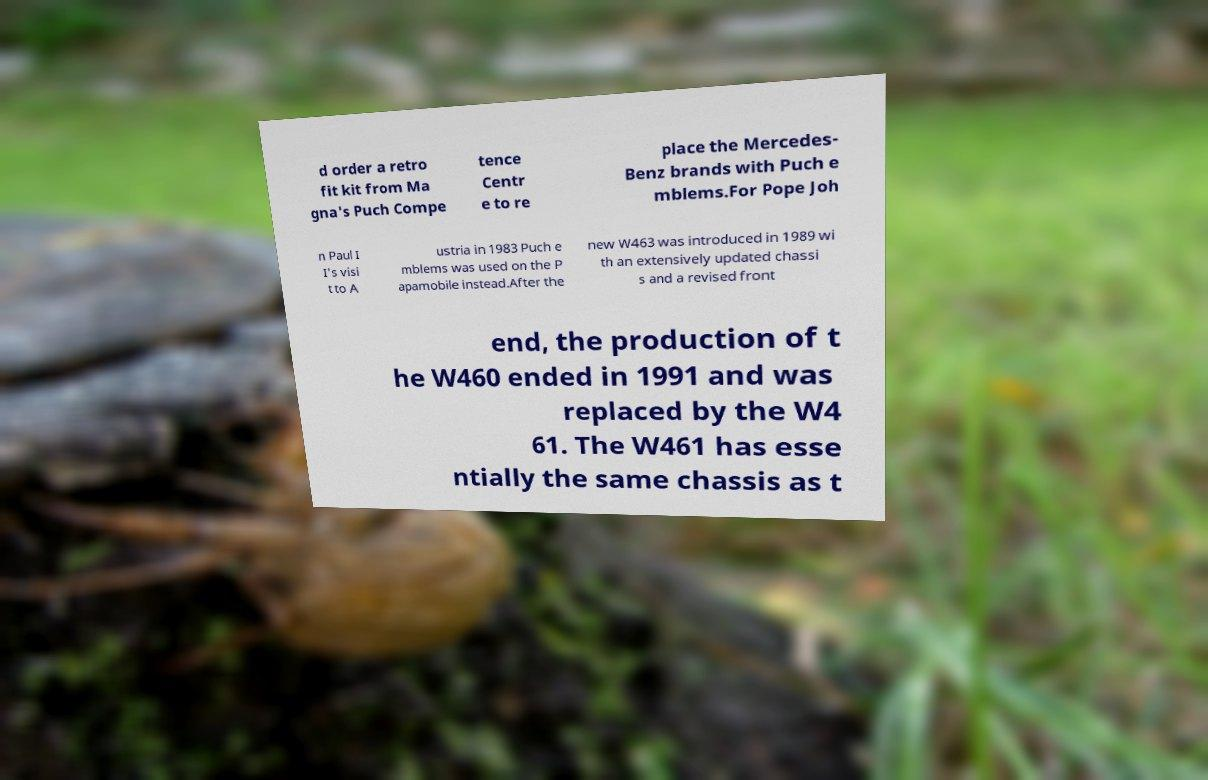For documentation purposes, I need the text within this image transcribed. Could you provide that? d order a retro fit kit from Ma gna's Puch Compe tence Centr e to re place the Mercedes- Benz brands with Puch e mblems.For Pope Joh n Paul I I's visi t to A ustria in 1983 Puch e mblems was used on the P apamobile instead.After the new W463 was introduced in 1989 wi th an extensively updated chassi s and a revised front end, the production of t he W460 ended in 1991 and was replaced by the W4 61. The W461 has esse ntially the same chassis as t 